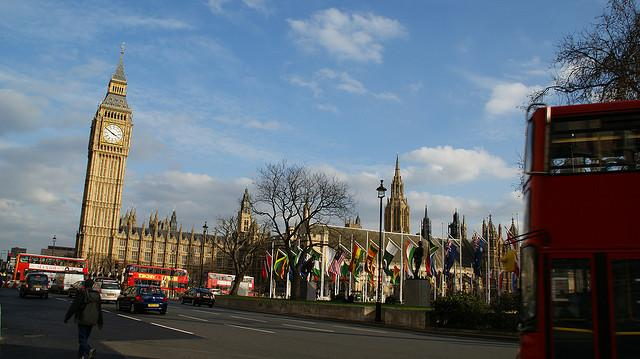Why are there so many buses?

Choices:
A) tourist destination
B) coincidence
C) break time
D) rush hour tourist destination 